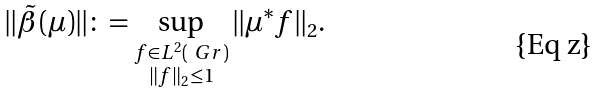<formula> <loc_0><loc_0><loc_500><loc_500>\| \tilde { \beta } ( \mu ) \| \colon = \sup _ { \substack { f \in L ^ { 2 } ( \ G r ) \\ \| f \| _ { 2 } \leq 1 } } \| \mu ^ { * } f \| _ { 2 } .</formula> 